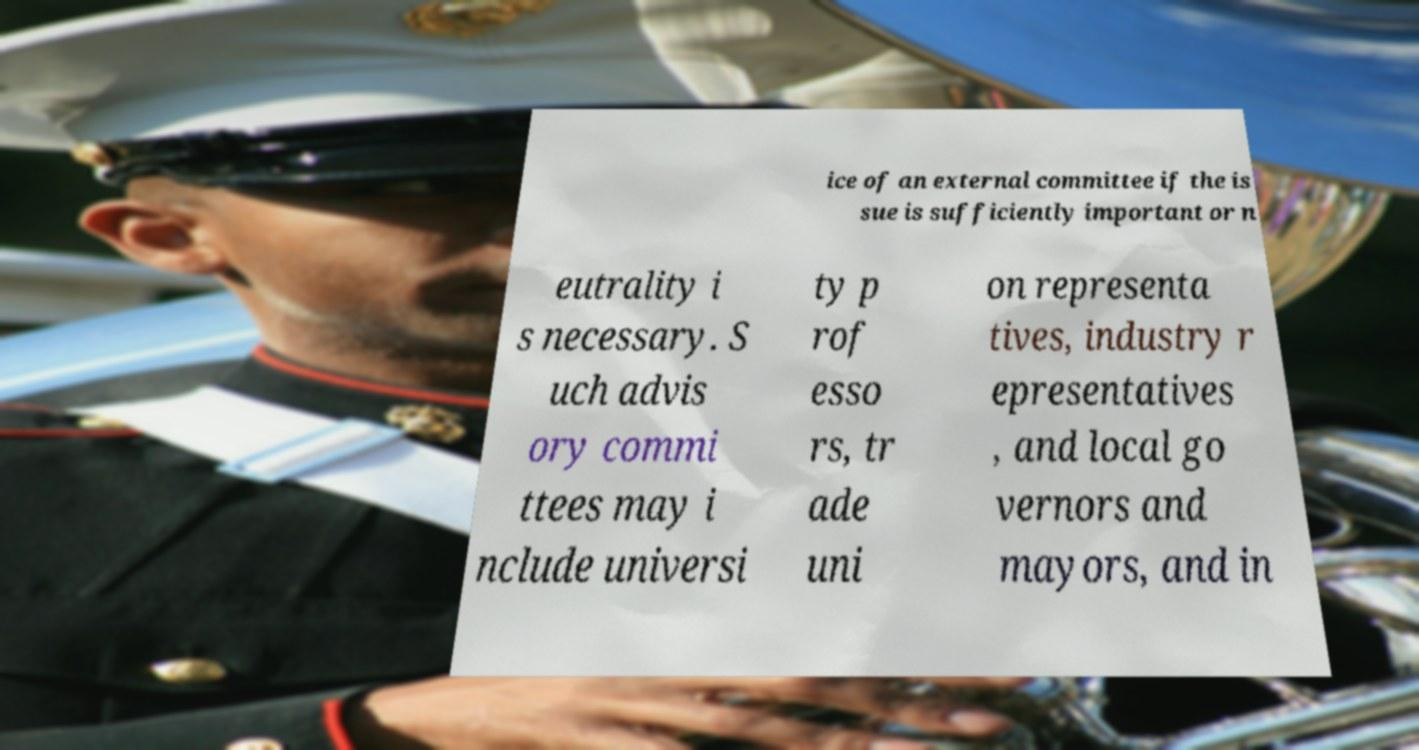There's text embedded in this image that I need extracted. Can you transcribe it verbatim? ice of an external committee if the is sue is sufficiently important or n eutrality i s necessary. S uch advis ory commi ttees may i nclude universi ty p rof esso rs, tr ade uni on representa tives, industry r epresentatives , and local go vernors and mayors, and in 